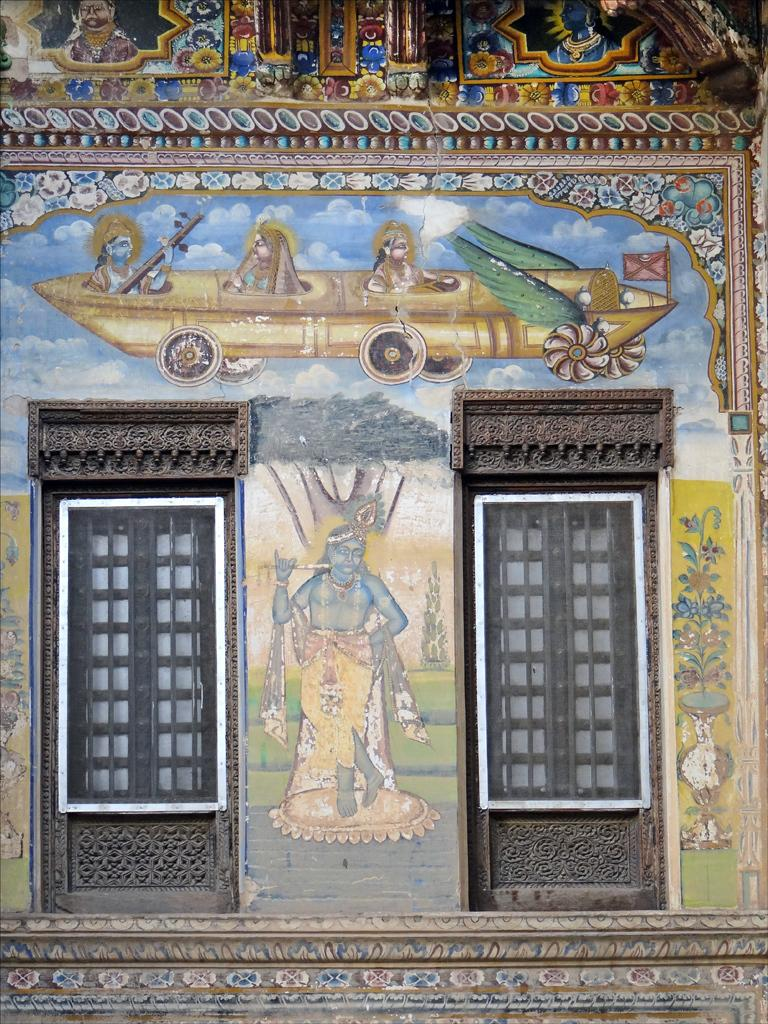What is on the wall in the image? There is a wall with paintings in the image. What do the paintings depict? The paintings depict god images. How many windows are visible in the image? There are two windows with glasses in the image. Where are the windows located? The windows are on the wall. What architectural detail can be seen at the top of the wall? There is architectural detail visible at the top of the wall. Can you see any fairies flying around the god images in the paintings? No, there are no fairies visible in the paintings or in the image. 